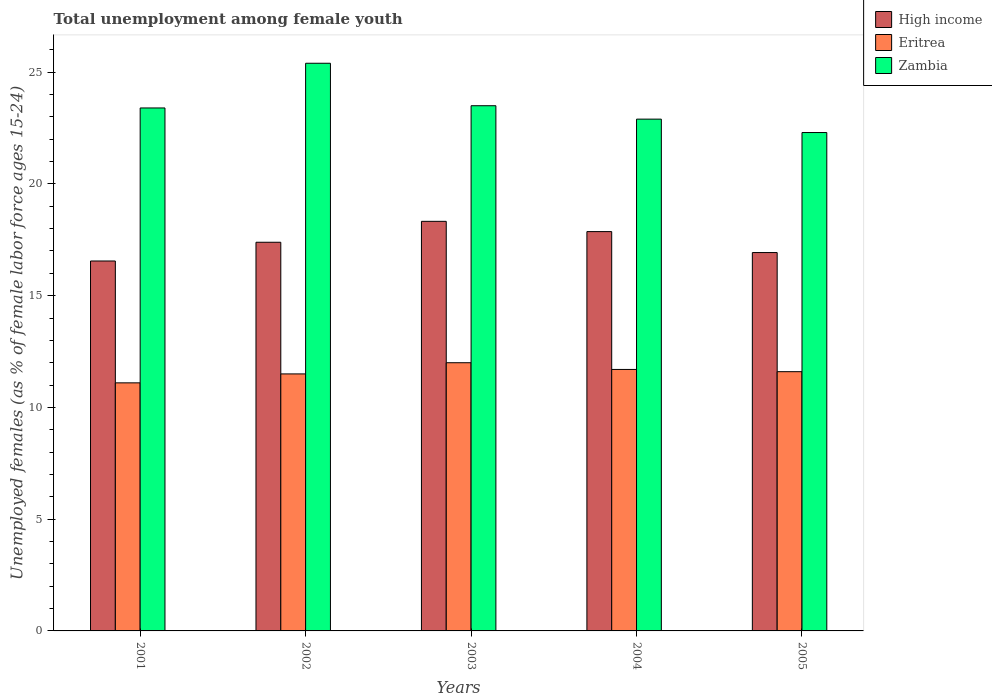Are the number of bars per tick equal to the number of legend labels?
Make the answer very short. Yes. Are the number of bars on each tick of the X-axis equal?
Provide a short and direct response. Yes. How many bars are there on the 5th tick from the left?
Give a very brief answer. 3. How many bars are there on the 5th tick from the right?
Ensure brevity in your answer.  3. What is the percentage of unemployed females in in Zambia in 2001?
Provide a succinct answer. 23.4. Across all years, what is the minimum percentage of unemployed females in in High income?
Provide a short and direct response. 16.55. In which year was the percentage of unemployed females in in Eritrea maximum?
Your response must be concise. 2003. In which year was the percentage of unemployed females in in High income minimum?
Offer a very short reply. 2001. What is the total percentage of unemployed females in in Eritrea in the graph?
Make the answer very short. 57.9. What is the difference between the percentage of unemployed females in in Eritrea in 2001 and that in 2002?
Your answer should be compact. -0.4. What is the difference between the percentage of unemployed females in in High income in 2005 and the percentage of unemployed females in in Zambia in 2004?
Ensure brevity in your answer.  -5.97. What is the average percentage of unemployed females in in High income per year?
Give a very brief answer. 17.41. In the year 2001, what is the difference between the percentage of unemployed females in in Eritrea and percentage of unemployed females in in High income?
Offer a very short reply. -5.45. What is the ratio of the percentage of unemployed females in in High income in 2002 to that in 2005?
Ensure brevity in your answer.  1.03. What is the difference between the highest and the second highest percentage of unemployed females in in High income?
Keep it short and to the point. 0.46. What is the difference between the highest and the lowest percentage of unemployed females in in High income?
Make the answer very short. 1.77. What does the 1st bar from the left in 2005 represents?
Offer a very short reply. High income. What does the 2nd bar from the right in 2004 represents?
Provide a succinct answer. Eritrea. How many years are there in the graph?
Offer a very short reply. 5. What is the title of the graph?
Ensure brevity in your answer.  Total unemployment among female youth. What is the label or title of the Y-axis?
Make the answer very short. Unemployed females (as % of female labor force ages 15-24). What is the Unemployed females (as % of female labor force ages 15-24) in High income in 2001?
Make the answer very short. 16.55. What is the Unemployed females (as % of female labor force ages 15-24) of Eritrea in 2001?
Give a very brief answer. 11.1. What is the Unemployed females (as % of female labor force ages 15-24) of Zambia in 2001?
Provide a short and direct response. 23.4. What is the Unemployed females (as % of female labor force ages 15-24) of High income in 2002?
Ensure brevity in your answer.  17.39. What is the Unemployed females (as % of female labor force ages 15-24) of Zambia in 2002?
Keep it short and to the point. 25.4. What is the Unemployed females (as % of female labor force ages 15-24) in High income in 2003?
Provide a short and direct response. 18.33. What is the Unemployed females (as % of female labor force ages 15-24) of Zambia in 2003?
Offer a very short reply. 23.5. What is the Unemployed females (as % of female labor force ages 15-24) in High income in 2004?
Keep it short and to the point. 17.87. What is the Unemployed females (as % of female labor force ages 15-24) of Eritrea in 2004?
Your answer should be compact. 11.7. What is the Unemployed females (as % of female labor force ages 15-24) of Zambia in 2004?
Keep it short and to the point. 22.9. What is the Unemployed females (as % of female labor force ages 15-24) in High income in 2005?
Offer a terse response. 16.93. What is the Unemployed females (as % of female labor force ages 15-24) of Eritrea in 2005?
Offer a terse response. 11.6. What is the Unemployed females (as % of female labor force ages 15-24) of Zambia in 2005?
Give a very brief answer. 22.3. Across all years, what is the maximum Unemployed females (as % of female labor force ages 15-24) in High income?
Your answer should be very brief. 18.33. Across all years, what is the maximum Unemployed females (as % of female labor force ages 15-24) of Zambia?
Keep it short and to the point. 25.4. Across all years, what is the minimum Unemployed females (as % of female labor force ages 15-24) in High income?
Ensure brevity in your answer.  16.55. Across all years, what is the minimum Unemployed females (as % of female labor force ages 15-24) in Eritrea?
Offer a terse response. 11.1. Across all years, what is the minimum Unemployed females (as % of female labor force ages 15-24) of Zambia?
Make the answer very short. 22.3. What is the total Unemployed females (as % of female labor force ages 15-24) of High income in the graph?
Provide a short and direct response. 87.07. What is the total Unemployed females (as % of female labor force ages 15-24) of Eritrea in the graph?
Keep it short and to the point. 57.9. What is the total Unemployed females (as % of female labor force ages 15-24) of Zambia in the graph?
Offer a terse response. 117.5. What is the difference between the Unemployed females (as % of female labor force ages 15-24) of High income in 2001 and that in 2002?
Make the answer very short. -0.84. What is the difference between the Unemployed females (as % of female labor force ages 15-24) in High income in 2001 and that in 2003?
Your answer should be compact. -1.77. What is the difference between the Unemployed females (as % of female labor force ages 15-24) of High income in 2001 and that in 2004?
Your answer should be very brief. -1.32. What is the difference between the Unemployed females (as % of female labor force ages 15-24) in Eritrea in 2001 and that in 2004?
Your answer should be compact. -0.6. What is the difference between the Unemployed females (as % of female labor force ages 15-24) of Zambia in 2001 and that in 2004?
Offer a very short reply. 0.5. What is the difference between the Unemployed females (as % of female labor force ages 15-24) in High income in 2001 and that in 2005?
Make the answer very short. -0.38. What is the difference between the Unemployed females (as % of female labor force ages 15-24) in High income in 2002 and that in 2003?
Offer a very short reply. -0.94. What is the difference between the Unemployed females (as % of female labor force ages 15-24) in Eritrea in 2002 and that in 2003?
Your answer should be compact. -0.5. What is the difference between the Unemployed females (as % of female labor force ages 15-24) of High income in 2002 and that in 2004?
Your answer should be compact. -0.48. What is the difference between the Unemployed females (as % of female labor force ages 15-24) in Eritrea in 2002 and that in 2004?
Keep it short and to the point. -0.2. What is the difference between the Unemployed females (as % of female labor force ages 15-24) in High income in 2002 and that in 2005?
Your answer should be very brief. 0.46. What is the difference between the Unemployed females (as % of female labor force ages 15-24) in Zambia in 2002 and that in 2005?
Your answer should be compact. 3.1. What is the difference between the Unemployed females (as % of female labor force ages 15-24) in High income in 2003 and that in 2004?
Make the answer very short. 0.46. What is the difference between the Unemployed females (as % of female labor force ages 15-24) in High income in 2003 and that in 2005?
Your answer should be very brief. 1.4. What is the difference between the Unemployed females (as % of female labor force ages 15-24) of High income in 2004 and that in 2005?
Provide a short and direct response. 0.94. What is the difference between the Unemployed females (as % of female labor force ages 15-24) in Eritrea in 2004 and that in 2005?
Your answer should be compact. 0.1. What is the difference between the Unemployed females (as % of female labor force ages 15-24) in High income in 2001 and the Unemployed females (as % of female labor force ages 15-24) in Eritrea in 2002?
Ensure brevity in your answer.  5.05. What is the difference between the Unemployed females (as % of female labor force ages 15-24) of High income in 2001 and the Unemployed females (as % of female labor force ages 15-24) of Zambia in 2002?
Make the answer very short. -8.85. What is the difference between the Unemployed females (as % of female labor force ages 15-24) in Eritrea in 2001 and the Unemployed females (as % of female labor force ages 15-24) in Zambia in 2002?
Ensure brevity in your answer.  -14.3. What is the difference between the Unemployed females (as % of female labor force ages 15-24) in High income in 2001 and the Unemployed females (as % of female labor force ages 15-24) in Eritrea in 2003?
Your answer should be compact. 4.55. What is the difference between the Unemployed females (as % of female labor force ages 15-24) in High income in 2001 and the Unemployed females (as % of female labor force ages 15-24) in Zambia in 2003?
Offer a terse response. -6.95. What is the difference between the Unemployed females (as % of female labor force ages 15-24) in Eritrea in 2001 and the Unemployed females (as % of female labor force ages 15-24) in Zambia in 2003?
Keep it short and to the point. -12.4. What is the difference between the Unemployed females (as % of female labor force ages 15-24) of High income in 2001 and the Unemployed females (as % of female labor force ages 15-24) of Eritrea in 2004?
Provide a short and direct response. 4.85. What is the difference between the Unemployed females (as % of female labor force ages 15-24) of High income in 2001 and the Unemployed females (as % of female labor force ages 15-24) of Zambia in 2004?
Your answer should be compact. -6.35. What is the difference between the Unemployed females (as % of female labor force ages 15-24) of Eritrea in 2001 and the Unemployed females (as % of female labor force ages 15-24) of Zambia in 2004?
Give a very brief answer. -11.8. What is the difference between the Unemployed females (as % of female labor force ages 15-24) in High income in 2001 and the Unemployed females (as % of female labor force ages 15-24) in Eritrea in 2005?
Ensure brevity in your answer.  4.95. What is the difference between the Unemployed females (as % of female labor force ages 15-24) of High income in 2001 and the Unemployed females (as % of female labor force ages 15-24) of Zambia in 2005?
Offer a terse response. -5.75. What is the difference between the Unemployed females (as % of female labor force ages 15-24) of High income in 2002 and the Unemployed females (as % of female labor force ages 15-24) of Eritrea in 2003?
Keep it short and to the point. 5.39. What is the difference between the Unemployed females (as % of female labor force ages 15-24) of High income in 2002 and the Unemployed females (as % of female labor force ages 15-24) of Zambia in 2003?
Offer a terse response. -6.11. What is the difference between the Unemployed females (as % of female labor force ages 15-24) of High income in 2002 and the Unemployed females (as % of female labor force ages 15-24) of Eritrea in 2004?
Your answer should be compact. 5.69. What is the difference between the Unemployed females (as % of female labor force ages 15-24) in High income in 2002 and the Unemployed females (as % of female labor force ages 15-24) in Zambia in 2004?
Keep it short and to the point. -5.51. What is the difference between the Unemployed females (as % of female labor force ages 15-24) of High income in 2002 and the Unemployed females (as % of female labor force ages 15-24) of Eritrea in 2005?
Provide a short and direct response. 5.79. What is the difference between the Unemployed females (as % of female labor force ages 15-24) of High income in 2002 and the Unemployed females (as % of female labor force ages 15-24) of Zambia in 2005?
Make the answer very short. -4.91. What is the difference between the Unemployed females (as % of female labor force ages 15-24) of Eritrea in 2002 and the Unemployed females (as % of female labor force ages 15-24) of Zambia in 2005?
Your response must be concise. -10.8. What is the difference between the Unemployed females (as % of female labor force ages 15-24) in High income in 2003 and the Unemployed females (as % of female labor force ages 15-24) in Eritrea in 2004?
Offer a very short reply. 6.63. What is the difference between the Unemployed females (as % of female labor force ages 15-24) in High income in 2003 and the Unemployed females (as % of female labor force ages 15-24) in Zambia in 2004?
Make the answer very short. -4.57. What is the difference between the Unemployed females (as % of female labor force ages 15-24) in High income in 2003 and the Unemployed females (as % of female labor force ages 15-24) in Eritrea in 2005?
Your response must be concise. 6.73. What is the difference between the Unemployed females (as % of female labor force ages 15-24) in High income in 2003 and the Unemployed females (as % of female labor force ages 15-24) in Zambia in 2005?
Provide a succinct answer. -3.97. What is the difference between the Unemployed females (as % of female labor force ages 15-24) of High income in 2004 and the Unemployed females (as % of female labor force ages 15-24) of Eritrea in 2005?
Offer a very short reply. 6.27. What is the difference between the Unemployed females (as % of female labor force ages 15-24) in High income in 2004 and the Unemployed females (as % of female labor force ages 15-24) in Zambia in 2005?
Provide a succinct answer. -4.43. What is the average Unemployed females (as % of female labor force ages 15-24) in High income per year?
Give a very brief answer. 17.41. What is the average Unemployed females (as % of female labor force ages 15-24) of Eritrea per year?
Ensure brevity in your answer.  11.58. What is the average Unemployed females (as % of female labor force ages 15-24) in Zambia per year?
Make the answer very short. 23.5. In the year 2001, what is the difference between the Unemployed females (as % of female labor force ages 15-24) in High income and Unemployed females (as % of female labor force ages 15-24) in Eritrea?
Make the answer very short. 5.45. In the year 2001, what is the difference between the Unemployed females (as % of female labor force ages 15-24) in High income and Unemployed females (as % of female labor force ages 15-24) in Zambia?
Provide a short and direct response. -6.85. In the year 2002, what is the difference between the Unemployed females (as % of female labor force ages 15-24) of High income and Unemployed females (as % of female labor force ages 15-24) of Eritrea?
Ensure brevity in your answer.  5.89. In the year 2002, what is the difference between the Unemployed females (as % of female labor force ages 15-24) of High income and Unemployed females (as % of female labor force ages 15-24) of Zambia?
Make the answer very short. -8.01. In the year 2002, what is the difference between the Unemployed females (as % of female labor force ages 15-24) in Eritrea and Unemployed females (as % of female labor force ages 15-24) in Zambia?
Your answer should be very brief. -13.9. In the year 2003, what is the difference between the Unemployed females (as % of female labor force ages 15-24) of High income and Unemployed females (as % of female labor force ages 15-24) of Eritrea?
Provide a succinct answer. 6.33. In the year 2003, what is the difference between the Unemployed females (as % of female labor force ages 15-24) of High income and Unemployed females (as % of female labor force ages 15-24) of Zambia?
Your answer should be compact. -5.17. In the year 2004, what is the difference between the Unemployed females (as % of female labor force ages 15-24) in High income and Unemployed females (as % of female labor force ages 15-24) in Eritrea?
Your answer should be compact. 6.17. In the year 2004, what is the difference between the Unemployed females (as % of female labor force ages 15-24) in High income and Unemployed females (as % of female labor force ages 15-24) in Zambia?
Keep it short and to the point. -5.03. In the year 2005, what is the difference between the Unemployed females (as % of female labor force ages 15-24) in High income and Unemployed females (as % of female labor force ages 15-24) in Eritrea?
Offer a very short reply. 5.33. In the year 2005, what is the difference between the Unemployed females (as % of female labor force ages 15-24) in High income and Unemployed females (as % of female labor force ages 15-24) in Zambia?
Ensure brevity in your answer.  -5.37. What is the ratio of the Unemployed females (as % of female labor force ages 15-24) in High income in 2001 to that in 2002?
Provide a short and direct response. 0.95. What is the ratio of the Unemployed females (as % of female labor force ages 15-24) of Eritrea in 2001 to that in 2002?
Provide a short and direct response. 0.97. What is the ratio of the Unemployed females (as % of female labor force ages 15-24) in Zambia in 2001 to that in 2002?
Make the answer very short. 0.92. What is the ratio of the Unemployed females (as % of female labor force ages 15-24) of High income in 2001 to that in 2003?
Give a very brief answer. 0.9. What is the ratio of the Unemployed females (as % of female labor force ages 15-24) of Eritrea in 2001 to that in 2003?
Give a very brief answer. 0.93. What is the ratio of the Unemployed females (as % of female labor force ages 15-24) in High income in 2001 to that in 2004?
Keep it short and to the point. 0.93. What is the ratio of the Unemployed females (as % of female labor force ages 15-24) in Eritrea in 2001 to that in 2004?
Offer a terse response. 0.95. What is the ratio of the Unemployed females (as % of female labor force ages 15-24) in Zambia in 2001 to that in 2004?
Your answer should be compact. 1.02. What is the ratio of the Unemployed females (as % of female labor force ages 15-24) in High income in 2001 to that in 2005?
Ensure brevity in your answer.  0.98. What is the ratio of the Unemployed females (as % of female labor force ages 15-24) of Eritrea in 2001 to that in 2005?
Give a very brief answer. 0.96. What is the ratio of the Unemployed females (as % of female labor force ages 15-24) of Zambia in 2001 to that in 2005?
Keep it short and to the point. 1.05. What is the ratio of the Unemployed females (as % of female labor force ages 15-24) of High income in 2002 to that in 2003?
Keep it short and to the point. 0.95. What is the ratio of the Unemployed females (as % of female labor force ages 15-24) of Eritrea in 2002 to that in 2003?
Your response must be concise. 0.96. What is the ratio of the Unemployed females (as % of female labor force ages 15-24) of Zambia in 2002 to that in 2003?
Your answer should be compact. 1.08. What is the ratio of the Unemployed females (as % of female labor force ages 15-24) of High income in 2002 to that in 2004?
Offer a very short reply. 0.97. What is the ratio of the Unemployed females (as % of female labor force ages 15-24) in Eritrea in 2002 to that in 2004?
Make the answer very short. 0.98. What is the ratio of the Unemployed females (as % of female labor force ages 15-24) of Zambia in 2002 to that in 2004?
Give a very brief answer. 1.11. What is the ratio of the Unemployed females (as % of female labor force ages 15-24) in High income in 2002 to that in 2005?
Your answer should be very brief. 1.03. What is the ratio of the Unemployed females (as % of female labor force ages 15-24) in Eritrea in 2002 to that in 2005?
Offer a terse response. 0.99. What is the ratio of the Unemployed females (as % of female labor force ages 15-24) in Zambia in 2002 to that in 2005?
Ensure brevity in your answer.  1.14. What is the ratio of the Unemployed females (as % of female labor force ages 15-24) in High income in 2003 to that in 2004?
Offer a terse response. 1.03. What is the ratio of the Unemployed females (as % of female labor force ages 15-24) in Eritrea in 2003 to that in 2004?
Provide a short and direct response. 1.03. What is the ratio of the Unemployed females (as % of female labor force ages 15-24) in Zambia in 2003 to that in 2004?
Your response must be concise. 1.03. What is the ratio of the Unemployed females (as % of female labor force ages 15-24) of High income in 2003 to that in 2005?
Provide a short and direct response. 1.08. What is the ratio of the Unemployed females (as % of female labor force ages 15-24) of Eritrea in 2003 to that in 2005?
Offer a terse response. 1.03. What is the ratio of the Unemployed females (as % of female labor force ages 15-24) in Zambia in 2003 to that in 2005?
Offer a very short reply. 1.05. What is the ratio of the Unemployed females (as % of female labor force ages 15-24) of High income in 2004 to that in 2005?
Make the answer very short. 1.06. What is the ratio of the Unemployed females (as % of female labor force ages 15-24) in Eritrea in 2004 to that in 2005?
Provide a succinct answer. 1.01. What is the ratio of the Unemployed females (as % of female labor force ages 15-24) of Zambia in 2004 to that in 2005?
Offer a terse response. 1.03. What is the difference between the highest and the second highest Unemployed females (as % of female labor force ages 15-24) in High income?
Make the answer very short. 0.46. What is the difference between the highest and the second highest Unemployed females (as % of female labor force ages 15-24) of Eritrea?
Provide a short and direct response. 0.3. What is the difference between the highest and the lowest Unemployed females (as % of female labor force ages 15-24) in High income?
Make the answer very short. 1.77. 